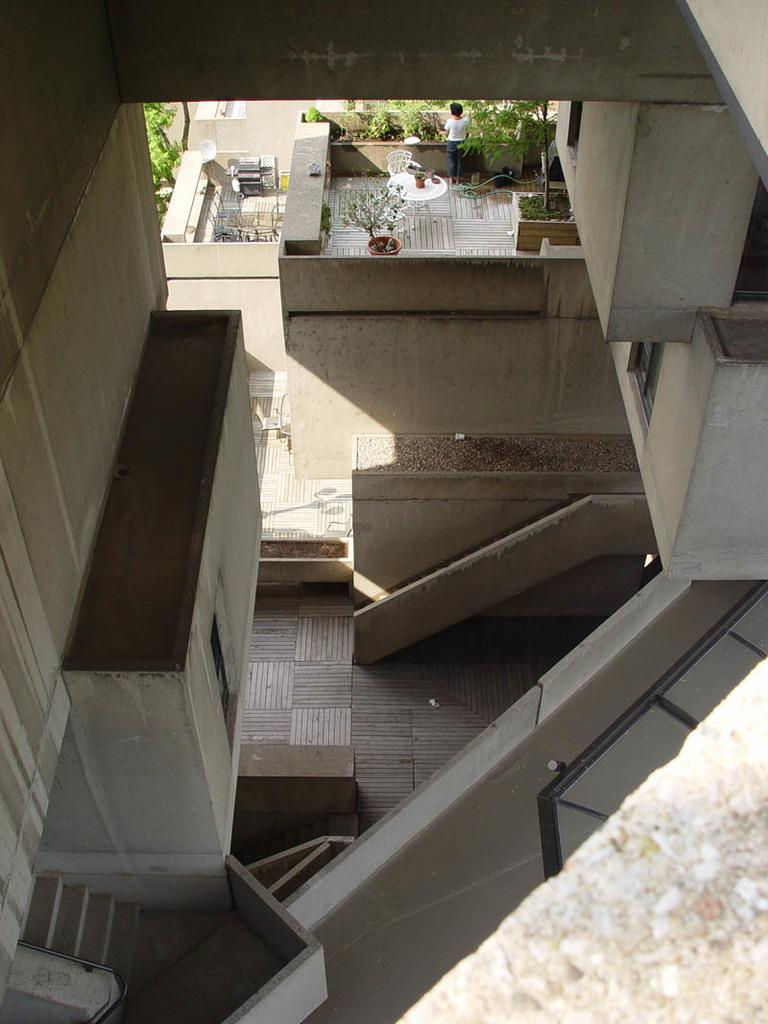What is the person in the image doing? There is a person standing on the roof in the image. What else can be seen on the roof? There are plants on the roof. What type of structure is visible in the image? There is a building in the image. How can someone access the roof in the image? There are stairs in the image. What type of pump is visible in the bedroom in the image? There is no bedroom or pump present in the image. 